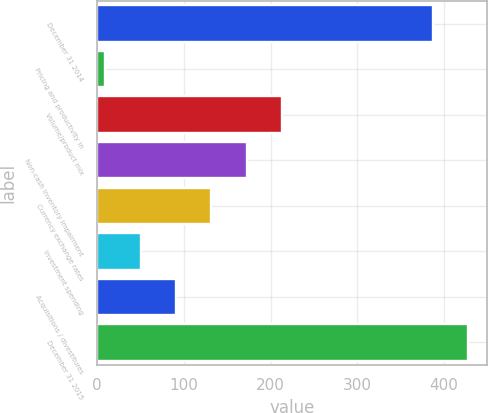Convert chart. <chart><loc_0><loc_0><loc_500><loc_500><bar_chart><fcel>December 31 2014<fcel>Pricing and productivity in<fcel>Volume/product mix<fcel>Non-cash inventory impairment<fcel>Currency exchange rates<fcel>Investment spending<fcel>Acquisitions / divestitures<fcel>December 31 2015<nl><fcel>387.3<fcel>9.1<fcel>213.55<fcel>172.66<fcel>131.77<fcel>49.99<fcel>90.88<fcel>428.19<nl></chart> 